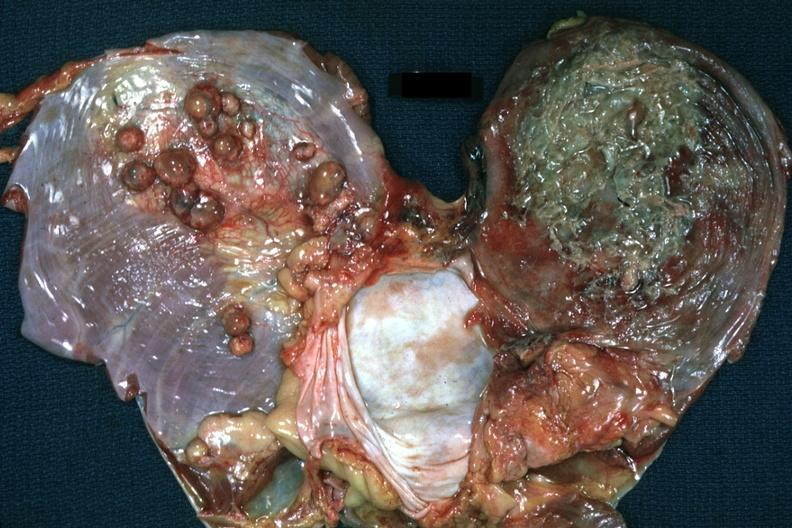what is present?
Answer the question using a single word or phrase. Soft tissue 